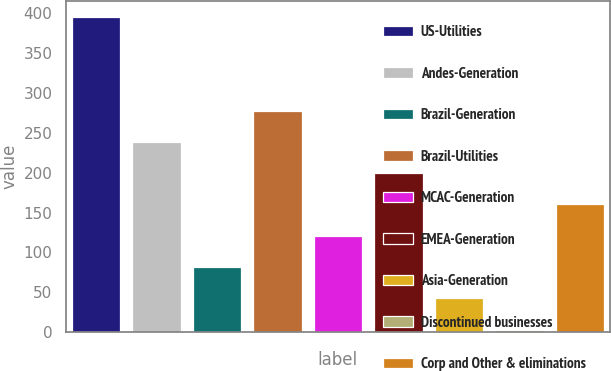Convert chart. <chart><loc_0><loc_0><loc_500><loc_500><bar_chart><fcel>US-Utilities<fcel>Andes-Generation<fcel>Brazil-Generation<fcel>Brazil-Utilities<fcel>MCAC-Generation<fcel>EMEA-Generation<fcel>Asia-Generation<fcel>Discontinued businesses<fcel>Corp and Other & eliminations<nl><fcel>396<fcel>238.8<fcel>81.6<fcel>278.1<fcel>120.9<fcel>199.5<fcel>42.3<fcel>3<fcel>160.2<nl></chart> 